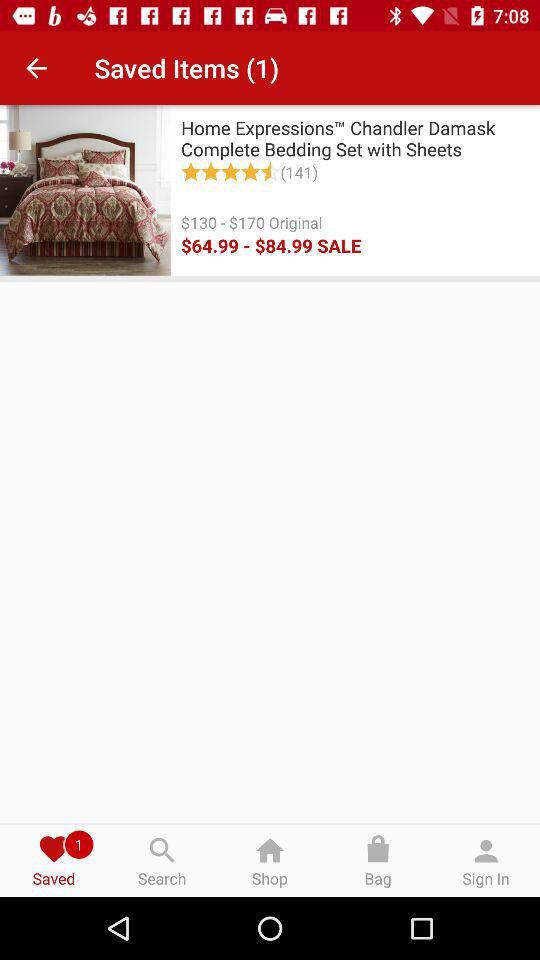What is the sale price range of the bedding set? The sale price range of the bedding set is from $64.99 to $84.99. 